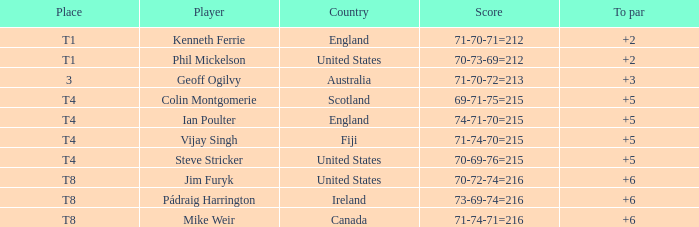What score to par did Mike Weir have? 6.0. 